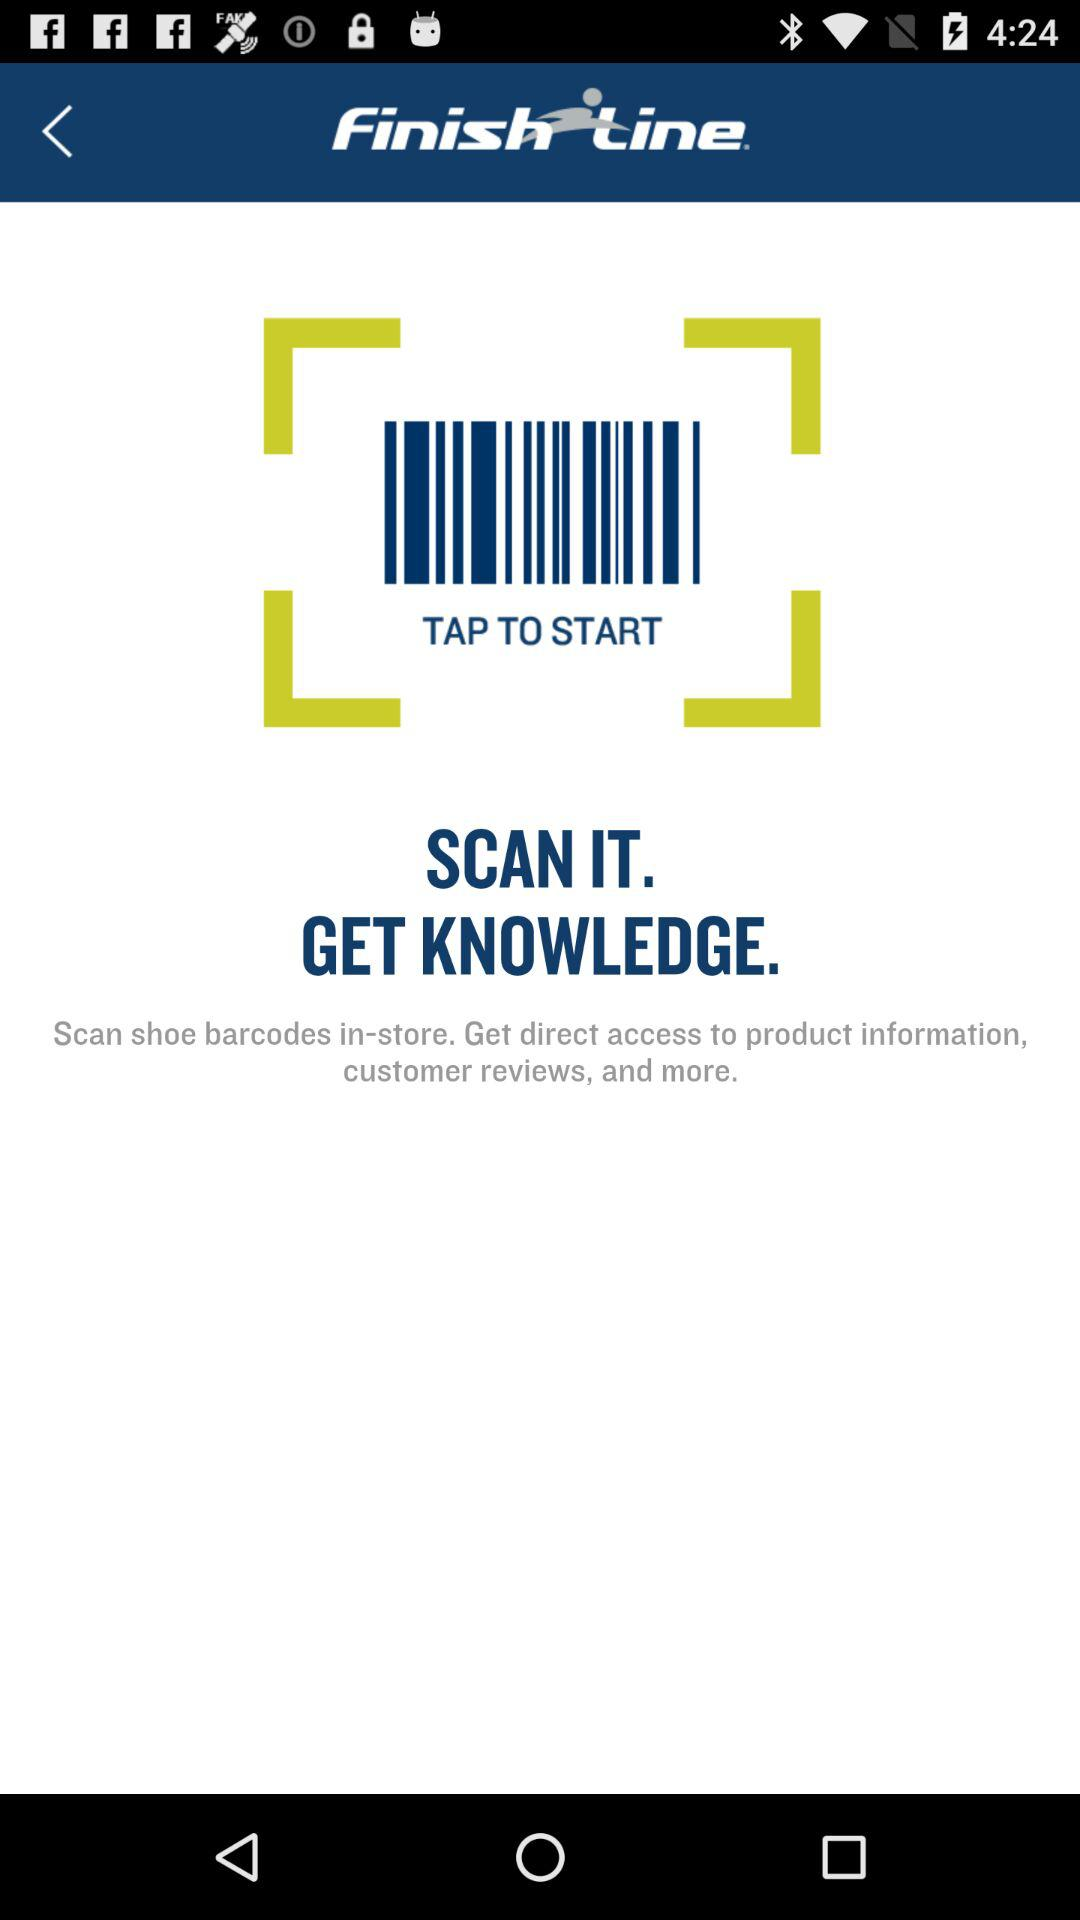What is the name of the application? The name of the application is "Finish Line". 